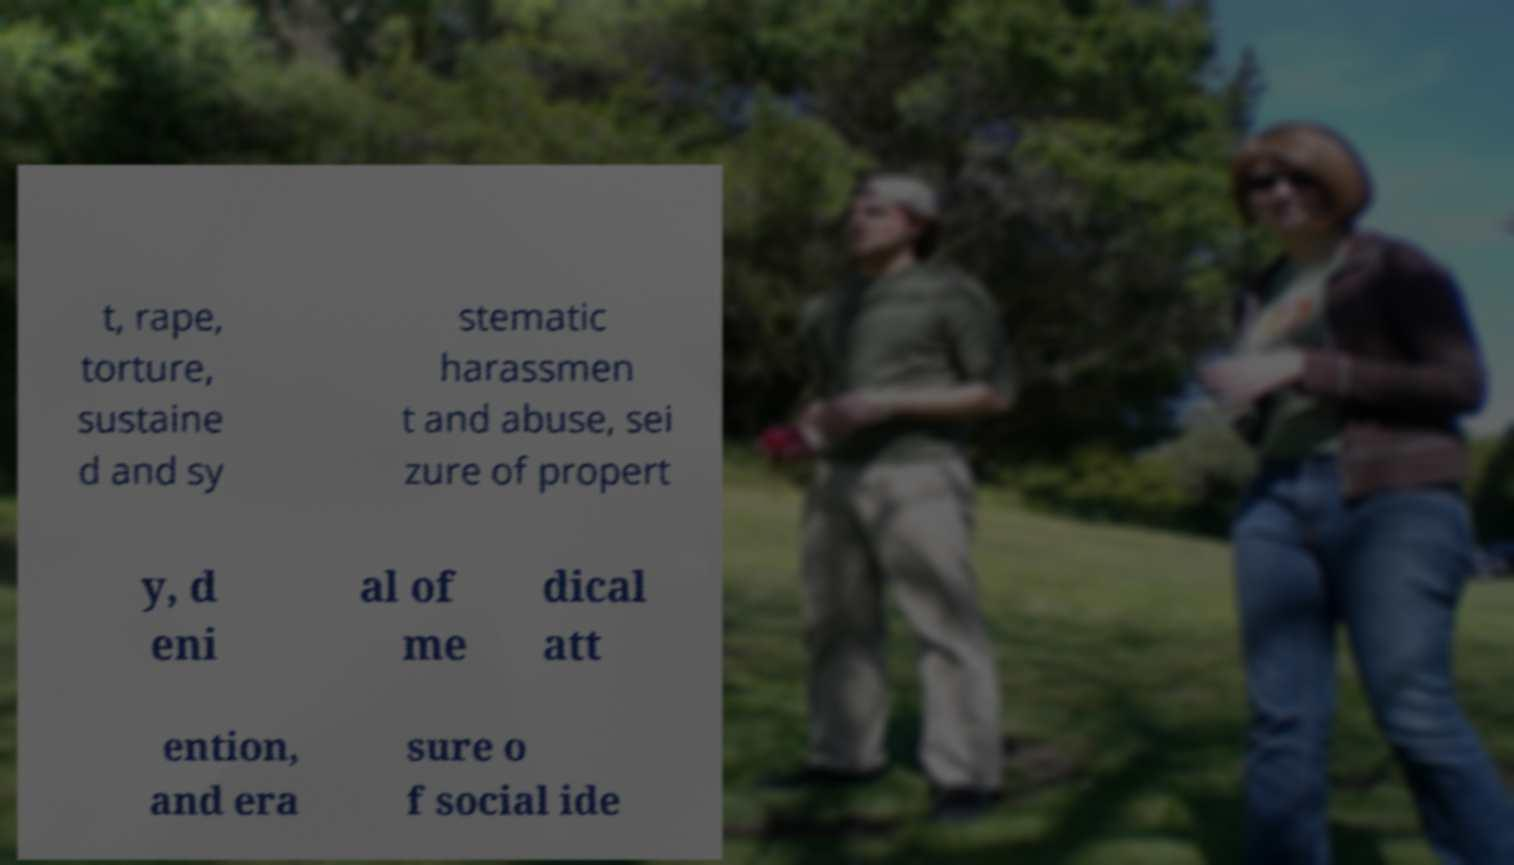Can you read and provide the text displayed in the image?This photo seems to have some interesting text. Can you extract and type it out for me? t, rape, torture, sustaine d and sy stematic harassmen t and abuse, sei zure of propert y, d eni al of me dical att ention, and era sure o f social ide 